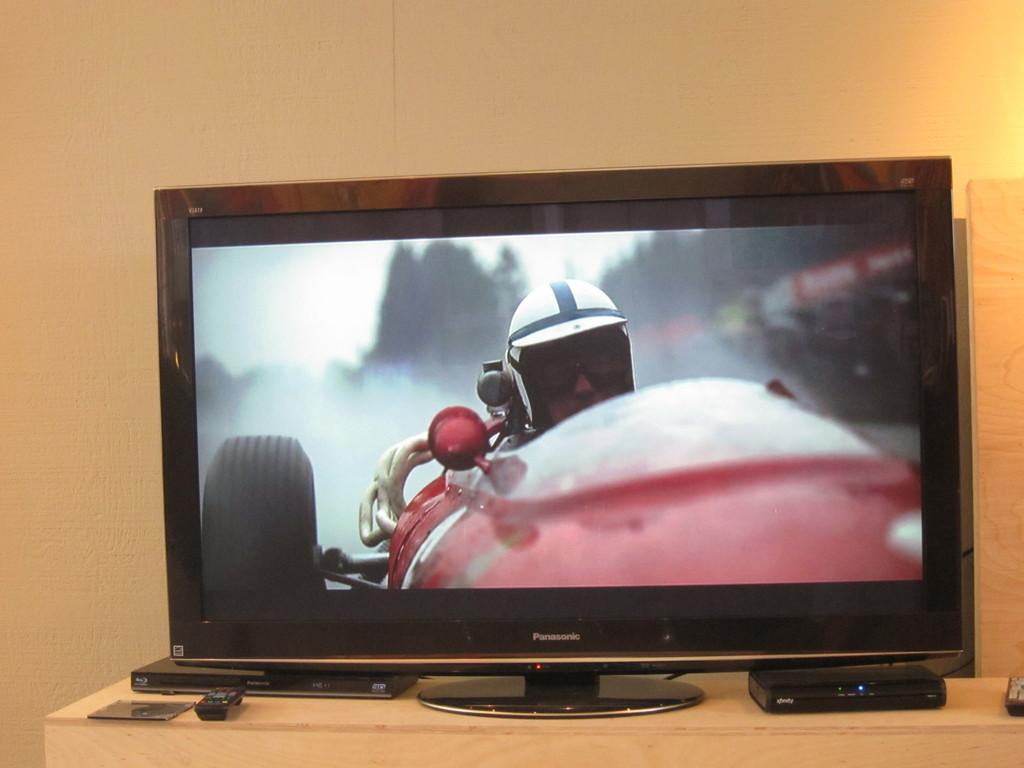<image>
Create a compact narrative representing the image presented. A Panasonic monitor shows a red car racing. 